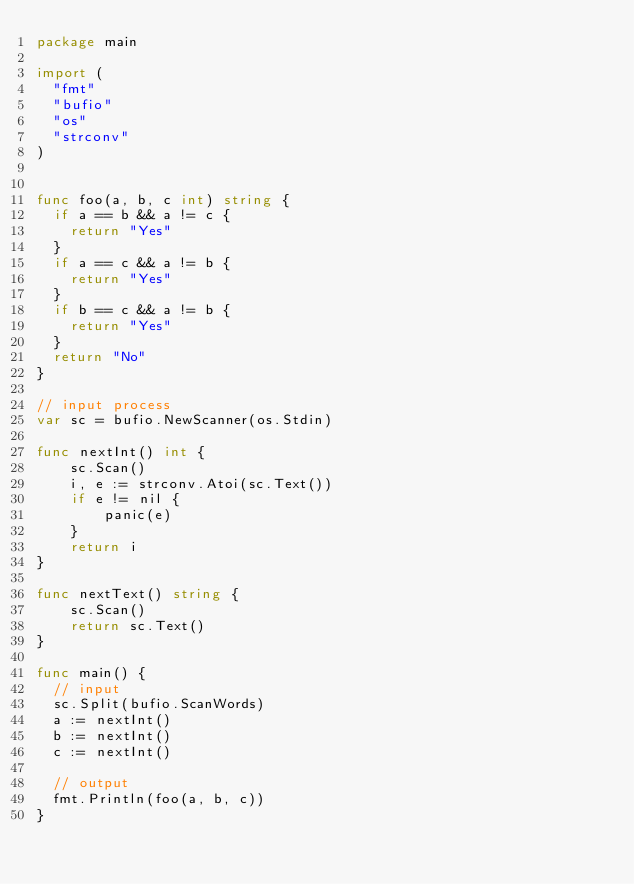Convert code to text. <code><loc_0><loc_0><loc_500><loc_500><_Go_>package main

import (
  "fmt"
  "bufio"
  "os"
  "strconv"
)


func foo(a, b, c int) string {
  if a == b && a != c {
    return "Yes"
  }
  if a == c && a != b {
    return "Yes"
  }
  if b == c && a != b {
    return "Yes"
  }
  return "No"
}

// input process
var sc = bufio.NewScanner(os.Stdin)

func nextInt() int {
    sc.Scan()
    i, e := strconv.Atoi(sc.Text())
    if e != nil {
        panic(e)
    }
    return i
}

func nextText() string {
    sc.Scan()
    return sc.Text()
}

func main() {
  // input
  sc.Split(bufio.ScanWords)
  a := nextInt()
  b := nextInt()
  c := nextInt()

  // output
  fmt.Println(foo(a, b, c))
}
</code> 